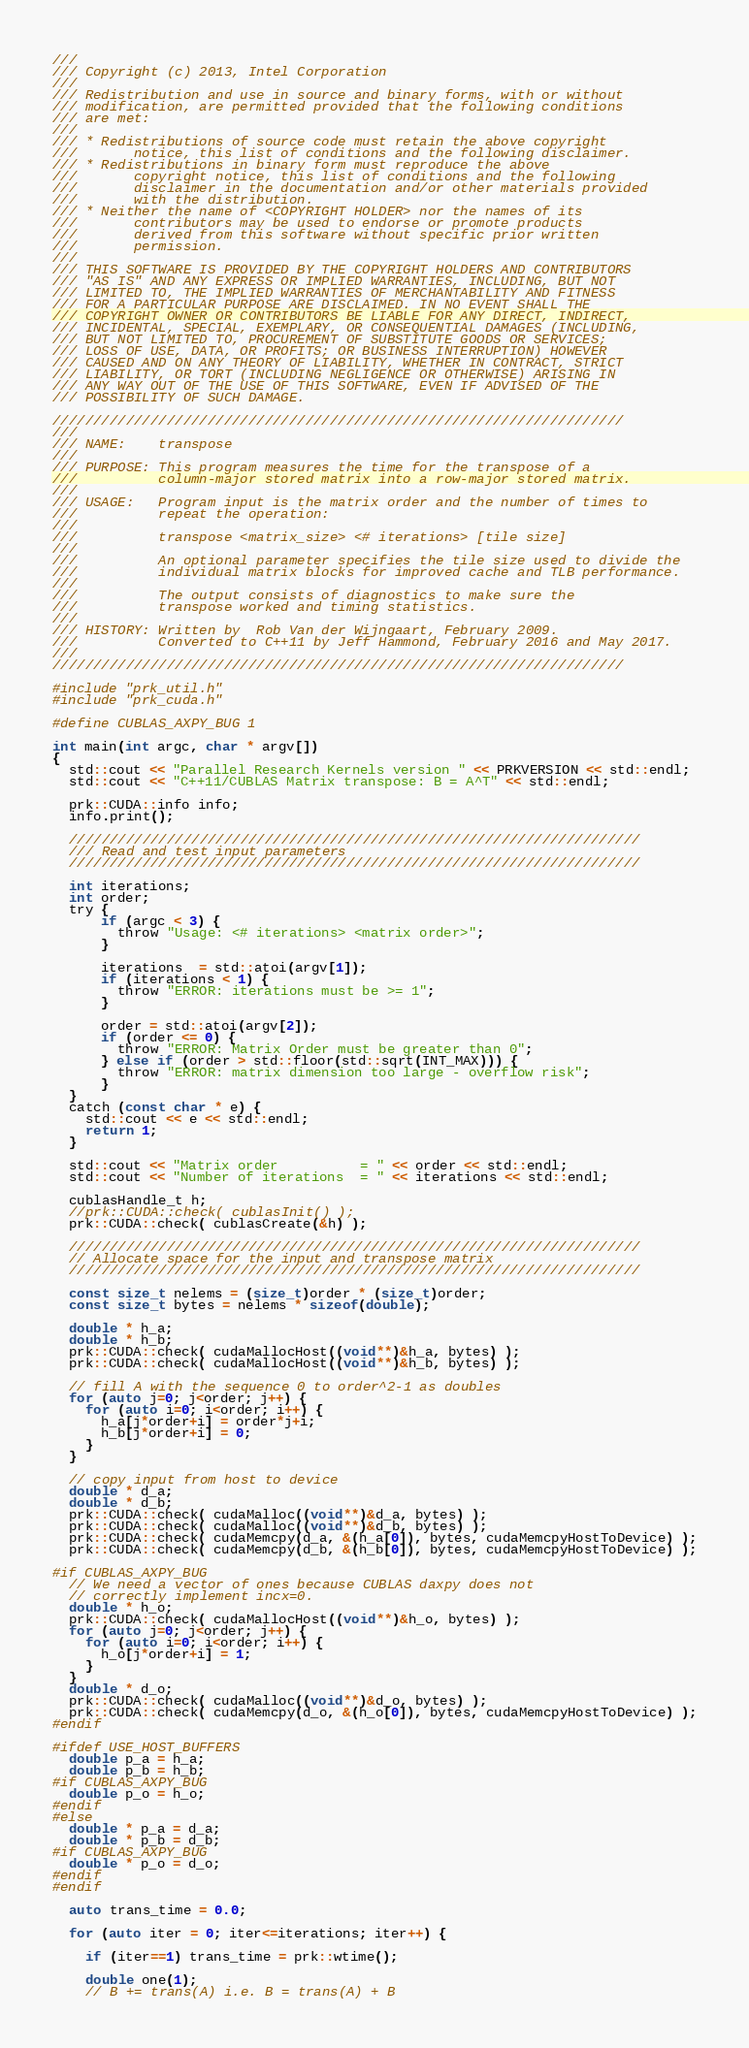<code> <loc_0><loc_0><loc_500><loc_500><_Cuda_>///
/// Copyright (c) 2013, Intel Corporation
///
/// Redistribution and use in source and binary forms, with or without
/// modification, are permitted provided that the following conditions
/// are met:
///
/// * Redistributions of source code must retain the above copyright
///       notice, this list of conditions and the following disclaimer.
/// * Redistributions in binary form must reproduce the above
///       copyright notice, this list of conditions and the following
///       disclaimer in the documentation and/or other materials provided
///       with the distribution.
/// * Neither the name of <COPYRIGHT HOLDER> nor the names of its
///       contributors may be used to endorse or promote products
///       derived from this software without specific prior written
///       permission.
///
/// THIS SOFTWARE IS PROVIDED BY THE COPYRIGHT HOLDERS AND CONTRIBUTORS
/// "AS IS" AND ANY EXPRESS OR IMPLIED WARRANTIES, INCLUDING, BUT NOT
/// LIMITED TO, THE IMPLIED WARRANTIES OF MERCHANTABILITY AND FITNESS
/// FOR A PARTICULAR PURPOSE ARE DISCLAIMED. IN NO EVENT SHALL THE
/// COPYRIGHT OWNER OR CONTRIBUTORS BE LIABLE FOR ANY DIRECT, INDIRECT,
/// INCIDENTAL, SPECIAL, EXEMPLARY, OR CONSEQUENTIAL DAMAGES (INCLUDING,
/// BUT NOT LIMITED TO, PROCUREMENT OF SUBSTITUTE GOODS OR SERVICES;
/// LOSS OF USE, DATA, OR PROFITS; OR BUSINESS INTERRUPTION) HOWEVER
/// CAUSED AND ON ANY THEORY OF LIABILITY, WHETHER IN CONTRACT, STRICT
/// LIABILITY, OR TORT (INCLUDING NEGLIGENCE OR OTHERWISE) ARISING IN
/// ANY WAY OUT OF THE USE OF THIS SOFTWARE, EVEN IF ADVISED OF THE
/// POSSIBILITY OF SUCH DAMAGE.

//////////////////////////////////////////////////////////////////////
///
/// NAME:    transpose
///
/// PURPOSE: This program measures the time for the transpose of a
///          column-major stored matrix into a row-major stored matrix.
///
/// USAGE:   Program input is the matrix order and the number of times to
///          repeat the operation:
///
///          transpose <matrix_size> <# iterations> [tile size]
///
///          An optional parameter specifies the tile size used to divide the
///          individual matrix blocks for improved cache and TLB performance.
///
///          The output consists of diagnostics to make sure the
///          transpose worked and timing statistics.
///
/// HISTORY: Written by  Rob Van der Wijngaart, February 2009.
///          Converted to C++11 by Jeff Hammond, February 2016 and May 2017.
///
//////////////////////////////////////////////////////////////////////

#include "prk_util.h"
#include "prk_cuda.h"

#define CUBLAS_AXPY_BUG 1

int main(int argc, char * argv[])
{
  std::cout << "Parallel Research Kernels version " << PRKVERSION << std::endl;
  std::cout << "C++11/CUBLAS Matrix transpose: B = A^T" << std::endl;

  prk::CUDA::info info;
  info.print();

  //////////////////////////////////////////////////////////////////////
  /// Read and test input parameters
  //////////////////////////////////////////////////////////////////////

  int iterations;
  int order;
  try {
      if (argc < 3) {
        throw "Usage: <# iterations> <matrix order>";
      }

      iterations  = std::atoi(argv[1]);
      if (iterations < 1) {
        throw "ERROR: iterations must be >= 1";
      }

      order = std::atoi(argv[2]);
      if (order <= 0) {
        throw "ERROR: Matrix Order must be greater than 0";
      } else if (order > std::floor(std::sqrt(INT_MAX))) {
        throw "ERROR: matrix dimension too large - overflow risk";
      }
  }
  catch (const char * e) {
    std::cout << e << std::endl;
    return 1;
  }

  std::cout << "Matrix order          = " << order << std::endl;
  std::cout << "Number of iterations  = " << iterations << std::endl;

  cublasHandle_t h;
  //prk::CUDA::check( cublasInit() );
  prk::CUDA::check( cublasCreate(&h) );

  //////////////////////////////////////////////////////////////////////
  // Allocate space for the input and transpose matrix
  //////////////////////////////////////////////////////////////////////

  const size_t nelems = (size_t)order * (size_t)order;
  const size_t bytes = nelems * sizeof(double);

  double * h_a;
  double * h_b;
  prk::CUDA::check( cudaMallocHost((void**)&h_a, bytes) );
  prk::CUDA::check( cudaMallocHost((void**)&h_b, bytes) );

  // fill A with the sequence 0 to order^2-1 as doubles
  for (auto j=0; j<order; j++) {
    for (auto i=0; i<order; i++) {
      h_a[j*order+i] = order*j+i;
      h_b[j*order+i] = 0;
    }
  }

  // copy input from host to device
  double * d_a;
  double * d_b;
  prk::CUDA::check( cudaMalloc((void**)&d_a, bytes) );
  prk::CUDA::check( cudaMalloc((void**)&d_b, bytes) );
  prk::CUDA::check( cudaMemcpy(d_a, &(h_a[0]), bytes, cudaMemcpyHostToDevice) );
  prk::CUDA::check( cudaMemcpy(d_b, &(h_b[0]), bytes, cudaMemcpyHostToDevice) );

#if CUBLAS_AXPY_BUG
  // We need a vector of ones because CUBLAS daxpy does not
  // correctly implement incx=0.
  double * h_o;
  prk::CUDA::check( cudaMallocHost((void**)&h_o, bytes) );
  for (auto j=0; j<order; j++) {
    for (auto i=0; i<order; i++) {
      h_o[j*order+i] = 1;
    }
  }
  double * d_o;
  prk::CUDA::check( cudaMalloc((void**)&d_o, bytes) );
  prk::CUDA::check( cudaMemcpy(d_o, &(h_o[0]), bytes, cudaMemcpyHostToDevice) );
#endif

#ifdef USE_HOST_BUFFERS
  double p_a = h_a;
  double p_b = h_b;
#if CUBLAS_AXPY_BUG
  double p_o = h_o;
#endif
#else
  double * p_a = d_a;
  double * p_b = d_b;
#if CUBLAS_AXPY_BUG
  double * p_o = d_o;
#endif
#endif

  auto trans_time = 0.0;

  for (auto iter = 0; iter<=iterations; iter++) {

    if (iter==1) trans_time = prk::wtime();

    double one(1);
    // B += trans(A) i.e. B = trans(A) + B</code> 